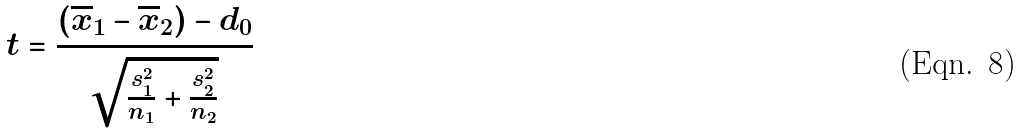Convert formula to latex. <formula><loc_0><loc_0><loc_500><loc_500>t = \frac { ( \overline { x } _ { 1 } - \overline { x } _ { 2 } ) - d _ { 0 } } { \sqrt { \frac { s _ { 1 } ^ { 2 } } { n _ { 1 } } + \frac { s _ { 2 } ^ { 2 } } { n _ { 2 } } } }</formula> 